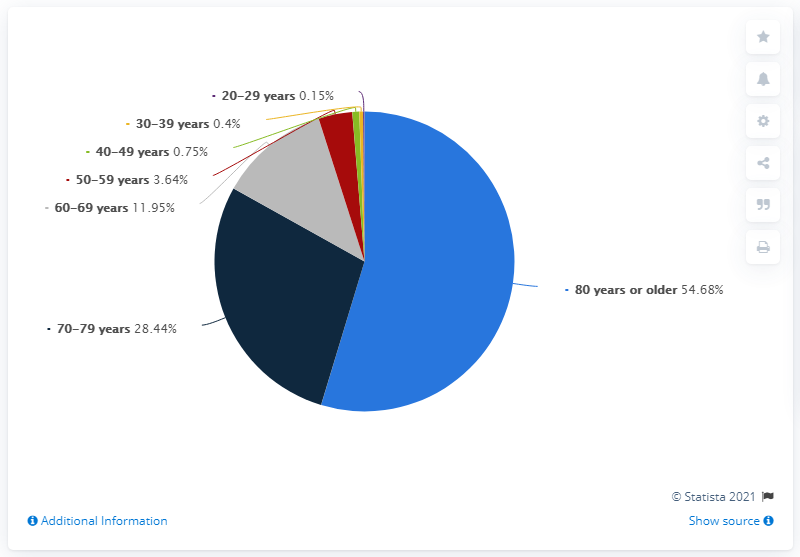Identify some key points in this picture. Of the patients who died from COVID-19, a significant proportion, 54.68%, were aged 80 or older. The age category with the highest number of deaths due to the COVID-19 virus is individuals 80 years or older. The patients who died from COVID-19 in South Korea as of June 24, 2021 were all 80 years old or older. According to the data, approximately 83.12% of people experienced death above the age of 70. 